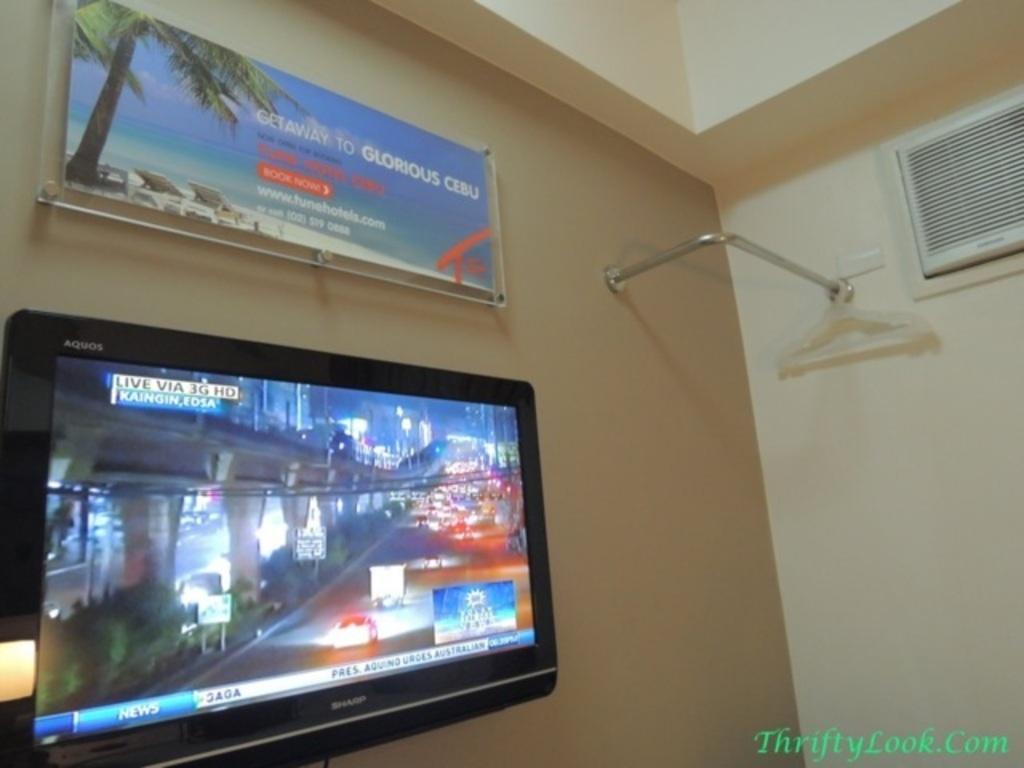What channel are they watching?
Offer a terse response. News. What website is shown in the lower right cornor?
Provide a succinct answer. Thriftylook.com. 